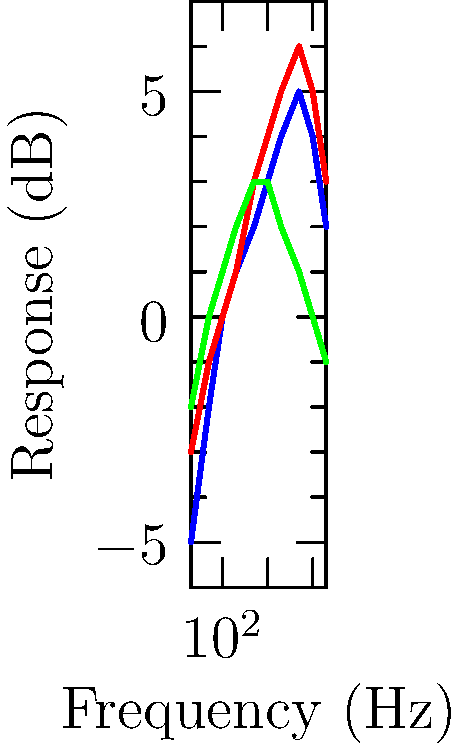Based on the frequency response curves shown for three different microphones (A, B, and C) commonly used in live-streaming setups, which microphone would be most suitable for capturing a wide range of instruments and vocals with minimal coloration? To determine which microphone is most suitable for capturing a wide range of instruments and vocals with minimal coloration, we need to analyze the frequency response curves:

1. Microphone A (blue):
   - Has a relatively flat response from 100 Hz to 1 kHz
   - Shows a gradual boost in the high frequencies (2-10 kHz)
   - Slight roll-off in the low frequencies (below 100 Hz) and extreme highs (above 10 kHz)

2. Microphone B (red):
   - Similar to Microphone A, but with more pronounced boosts and cuts
   - Stronger boost in high frequencies (2-10 kHz)
   - More significant roll-off in low frequencies (below 100 Hz)

3. Microphone C (green):
   - The flattest overall response across the entire frequency spectrum
   - Slight boost in the midrange (500 Hz - 2 kHz)
   - Gentle roll-off in both low and high frequencies

For capturing a wide range of instruments and vocals with minimal coloration, we want a microphone with the flattest frequency response. This ensures that the microphone reproduces the sound source as accurately as possible without adding its own character or "color" to the sound.

Microphone C has the flattest overall response, with only slight variations across the frequency spectrum. This makes it the most suitable for capturing a wide range of instruments and vocals without significantly altering their natural sound.

Microphones A and B have more pronounced boosts in the high frequencies, which could potentially add brightness or harshness to some instruments or vocals. They also have more significant low-frequency roll-off, which might reduce the fullness of low-frequency instruments.
Answer: Microphone C 